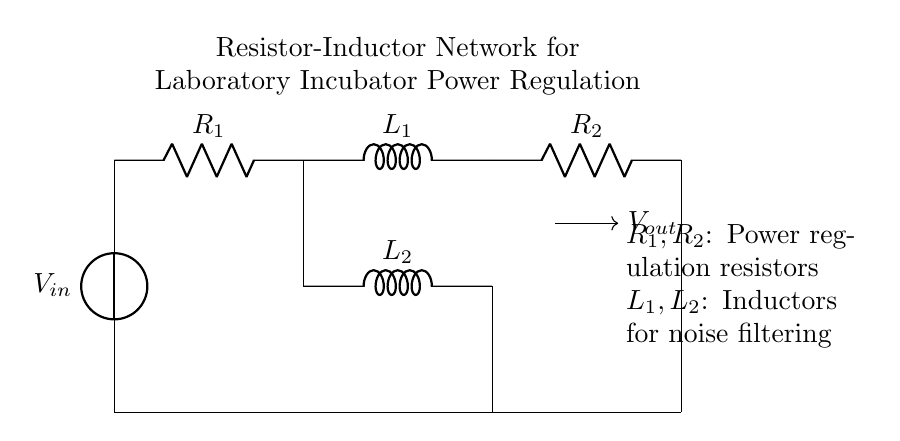What are the components in this circuit? The circuit contains two resistors and two inductors. The components are identified visually in the diagram, as labels next to the symbols indicate them clearly.
Answer: Resistors and inductors What does R1 represent? R1 is a resistor, which is part of the power regulation process within the circuit, helping to control the current flowing through.
Answer: Power regulation resistor What type of circuit is this? This circuit can be categorized as a resistor-inductor network, which is characterized by the presence of resistors and inductors to manage power supply and reduce noise.
Answer: Resistor-inductor How many inductors are in the circuit? The circuit includes two inductors: L1 and L2, as indicated by the labeled symbols in the diagram.
Answer: Two What is the function of inductors in this network? Inductors, like L1 and L2, serve to filter noise in the power supply, stabilizing the current flow, which is essential for maintaining consistent conditions in the incubator.
Answer: Noise filtering What is the output voltage's symbol? The output voltage is represented by the symbol Vout, which is shown with an arrow indicating the flow direction.
Answer: Vout What happens to the current as it passes through R1 and L1? As the current passes through R1, the resistor limits the current flow, while L1 smooths out the current changes due to its inductive properties, which is important for stable operation.
Answer: Current regulation 